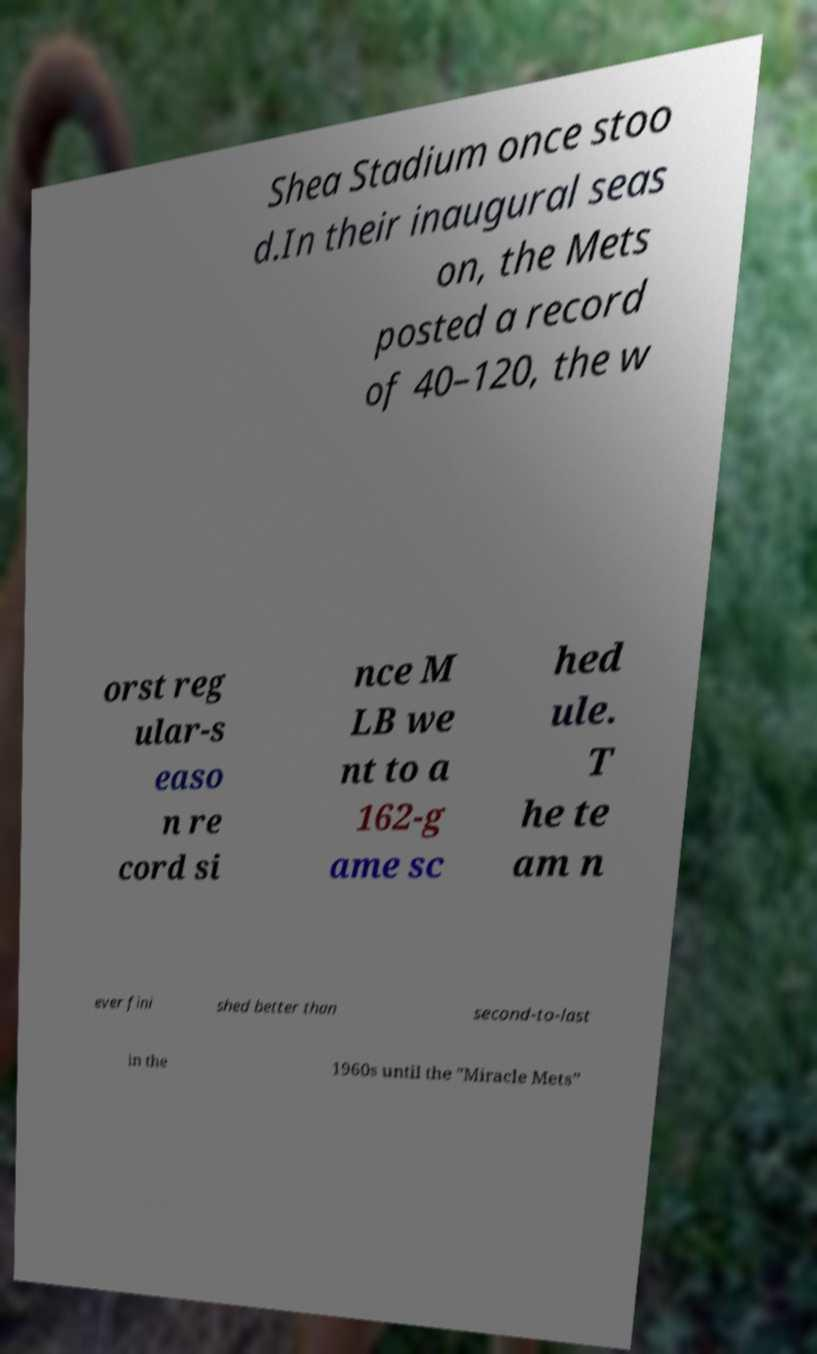There's text embedded in this image that I need extracted. Can you transcribe it verbatim? Shea Stadium once stoo d.In their inaugural seas on, the Mets posted a record of 40–120, the w orst reg ular-s easo n re cord si nce M LB we nt to a 162-g ame sc hed ule. T he te am n ever fini shed better than second-to-last in the 1960s until the "Miracle Mets" 